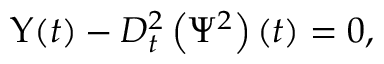Convert formula to latex. <formula><loc_0><loc_0><loc_500><loc_500>\Upsilon ( t ) - D _ { t } ^ { 2 } \left ( \Psi ^ { 2 } \right ) ( t ) = 0 ,</formula> 